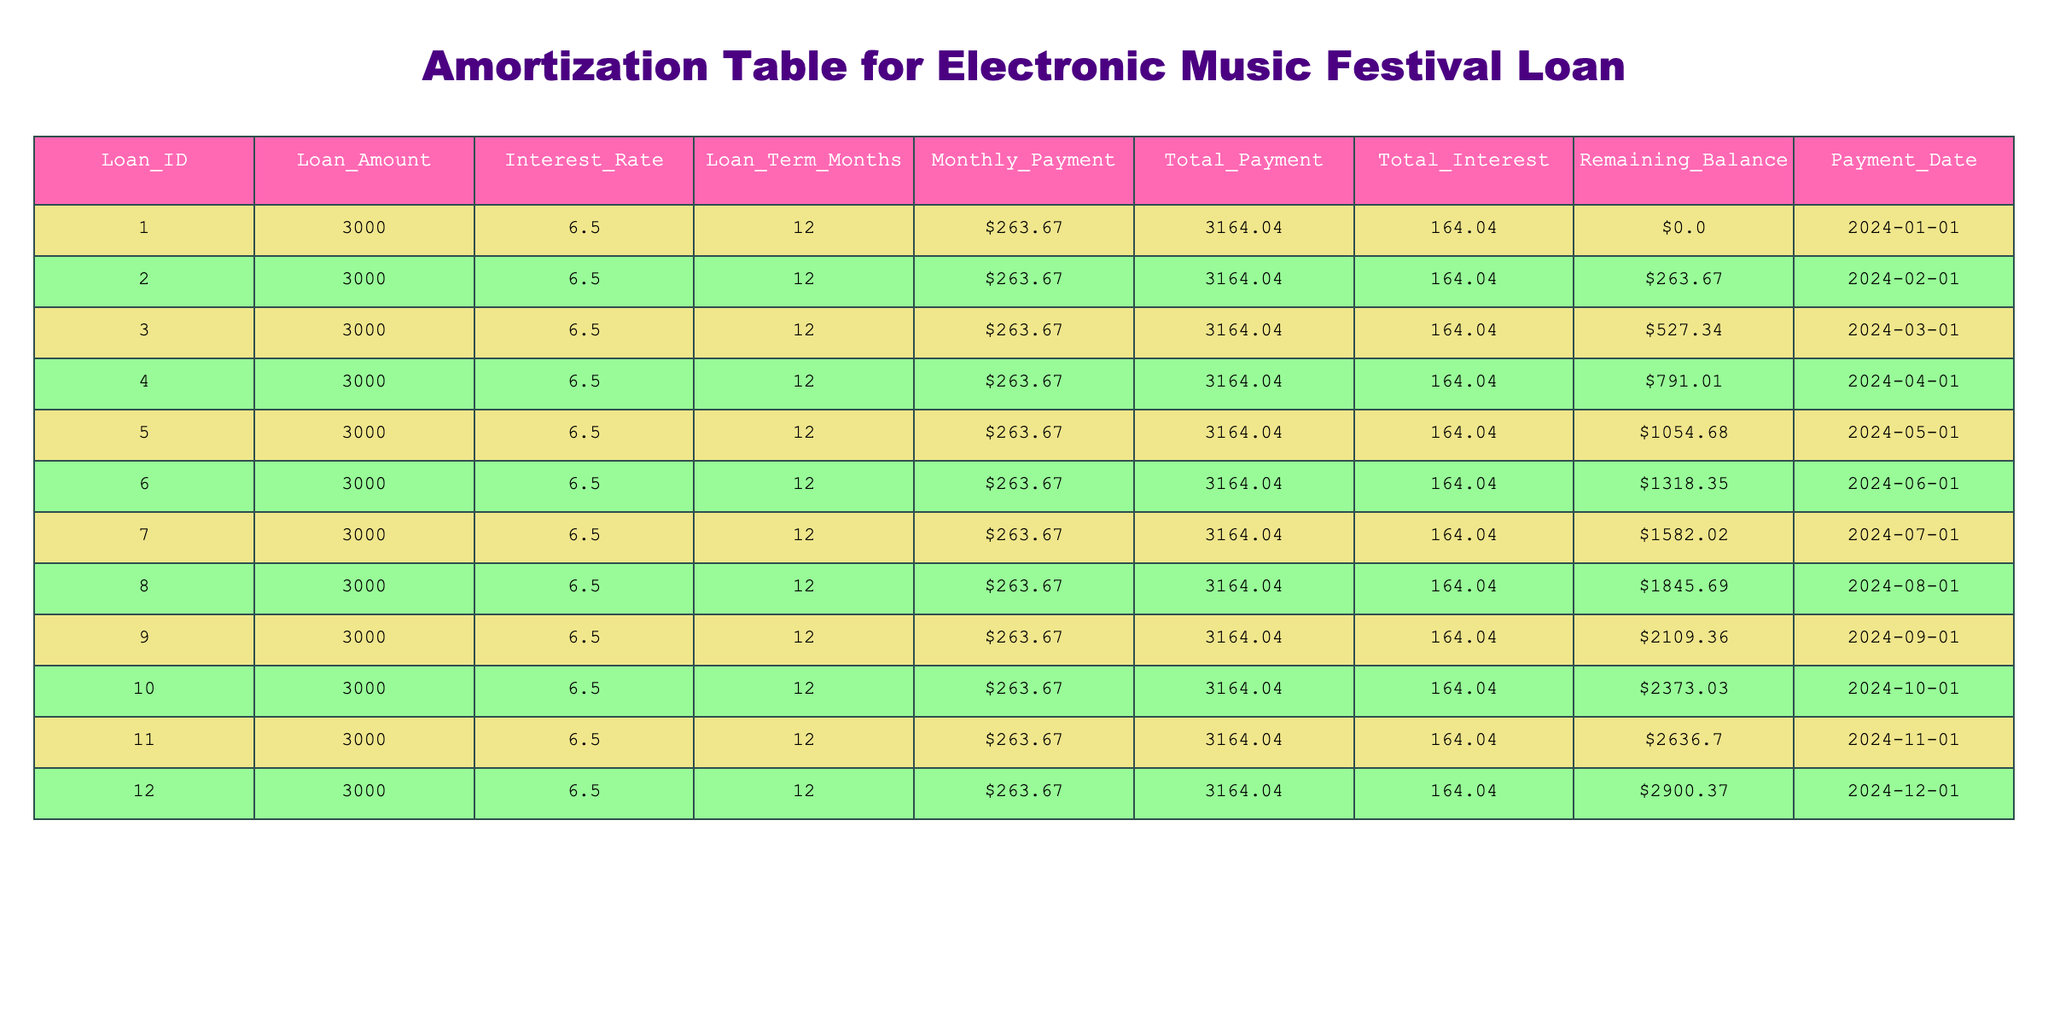What is the total amount paid at the end of the loan term? By looking at the table, the total payment made at the end of the loan term can be found in the "Total_Payment" column for the last payment date, which is $3164.04.
Answer: 3164.04 What is the remaining balance after the first payment? The remaining balance after the first payment is shown in the "Remaining_Balance" column for the first payment date, which is $263.67.
Answer: 263.67 Is the Interest Rate of the loan greater than 5%? The Interest Rate given in the table is 6.5%, which is indeed greater than 5%.
Answer: Yes What is the average monthly payment for this loan? The monthly payment for each month is constant at $263.67, thus there are 12 payments, making the total monthly payment multiplied by 12 equal to $3164.04. The average remains $263.67 for each payment. Therefore, the average monthly payment is simply that value.
Answer: 263.67 How much interest is paid after 6 months? To find the interest paid after 6 months, look at the "Total_Interest" column at the 6th month, which shows $164.04. Therefore, the total interest paid after 6 months is also $164.04 as this is a single static interest added for the entire term and calculated in segments.
Answer: 164.04 What is the difference between the loan amount and the total payment? The loan amount is $3000, and the total payment is $3164.04. The difference can be calculated by subtracting the loan amount from the total payment: $3164.04 - $3000 = $164.04.
Answer: 164.04 What is the remaining balance after four months? The remaining balance after the fourth month is listed in the "Remaining_Balance" column on the same month line, which indicates a balance of $791.01 after the fourth payment.
Answer: 791.01 Does the loan term extend beyond 12 months? The loan term specified in the table is 12 months, which does not extend beyond this period.
Answer: No What is the total interest paid by the end of the loan term? By referring to the "Total_Interest" column for the last payment date, we see the total interest paid by the end of the loan term is $164.04. Therefore, this value represents the cumulative interest paid over the duration of the loan.
Answer: 164.04 